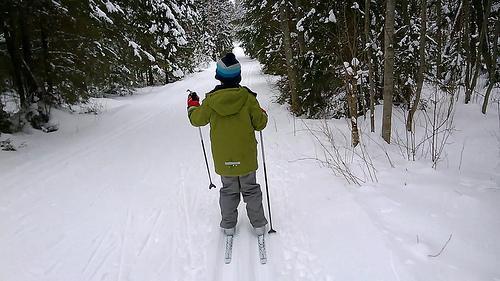How many people are in the photo?
Give a very brief answer. 1. 